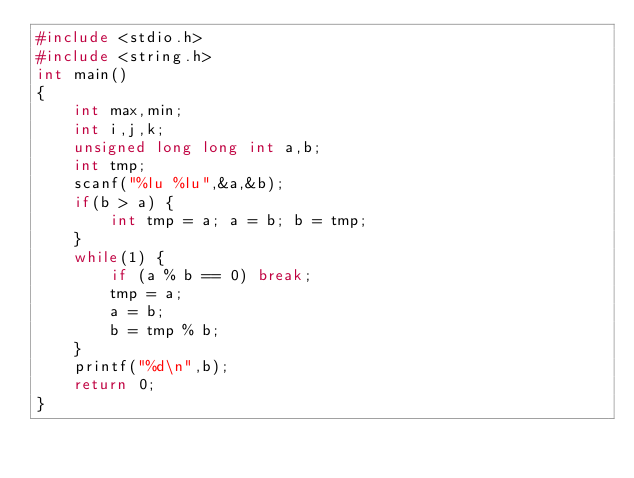Convert code to text. <code><loc_0><loc_0><loc_500><loc_500><_C_>#include <stdio.h>
#include <string.h>
int main()
{
    int max,min;
    int i,j,k;
    unsigned long long int a,b;
    int tmp;
    scanf("%lu %lu",&a,&b);
    if(b > a) {
        int tmp = a; a = b; b = tmp;
    }
    while(1) {
        if (a % b == 0) break;
        tmp = a;
        a = b;
        b = tmp % b;
    }
    printf("%d\n",b);
    return 0;
}</code> 